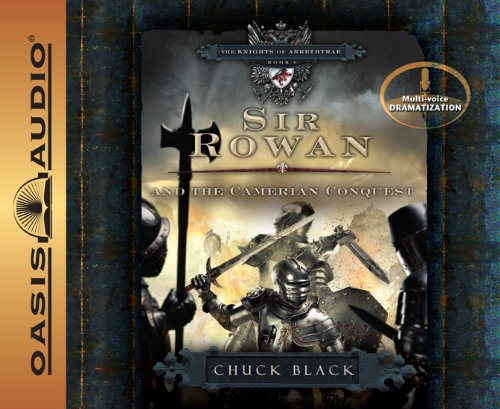What is the genre of this book? The genre of the book is categorized under 'Teen & Young Adult'. This classification reflects its intended audience and the adventurous themes that appeal to younger readers looking for exciting and heroic tales. 